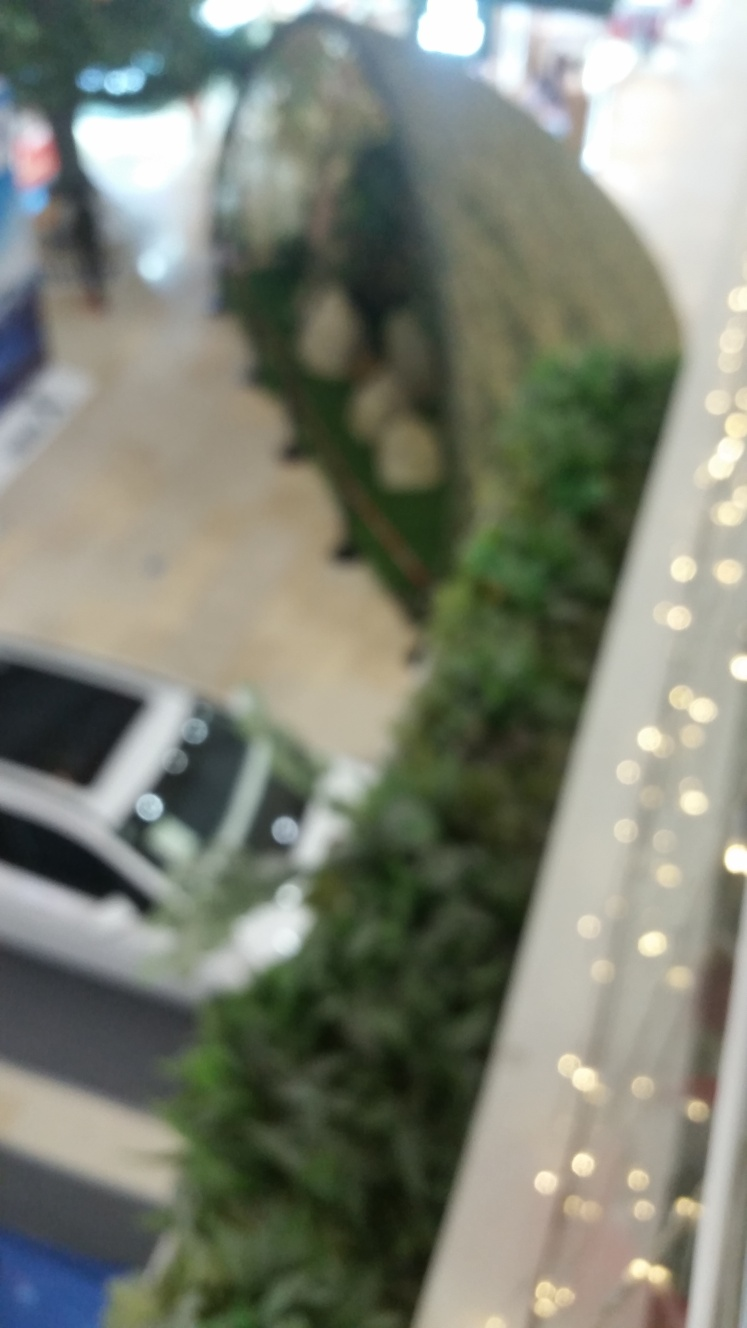What kind of place does this image depict? While the image is not in clear focus, it appears to depict an indoor public space, such as a shopping mall, due to the presence of commercial signage and what looks like a kiosk or booth surrounded by plants. The blurry outlines suggest a bustling environment, possibly with shoppers. What time of year might it be in this image? Determining the time of year from this image is quite challenging due to the lack of visible seasonal indicators and the blurriness of the photo. However, the presence of bright lights could hint at some kind of festive decoration, which might suggest a holiday season. 